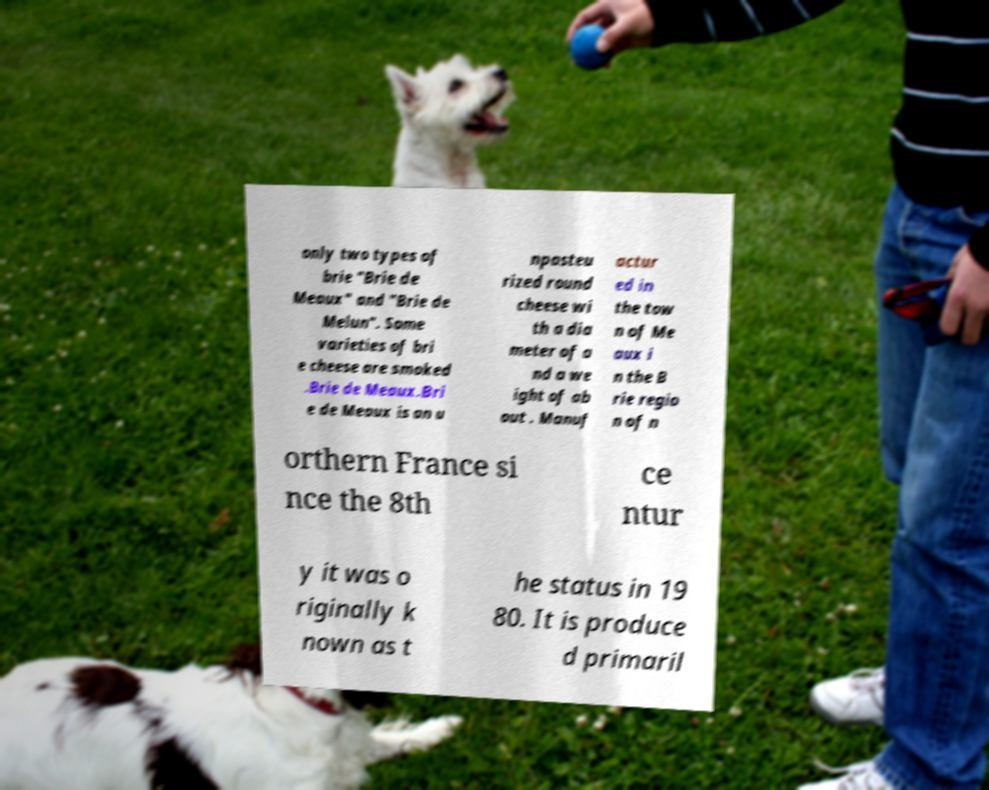I need the written content from this picture converted into text. Can you do that? only two types of brie "Brie de Meaux" and "Brie de Melun". Some varieties of bri e cheese are smoked .Brie de Meaux.Bri e de Meaux is an u npasteu rized round cheese wi th a dia meter of a nd a we ight of ab out . Manuf actur ed in the tow n of Me aux i n the B rie regio n of n orthern France si nce the 8th ce ntur y it was o riginally k nown as t he status in 19 80. It is produce d primaril 